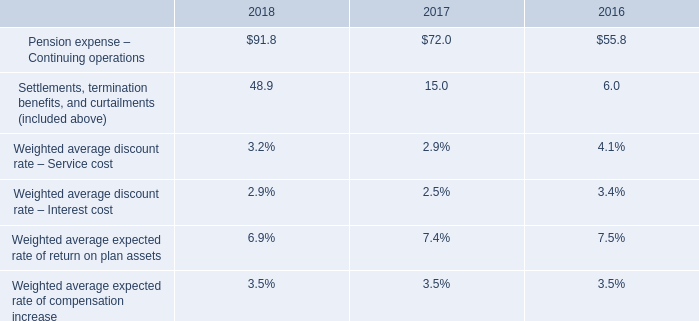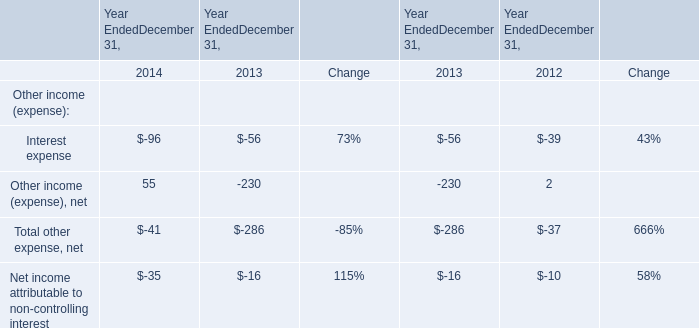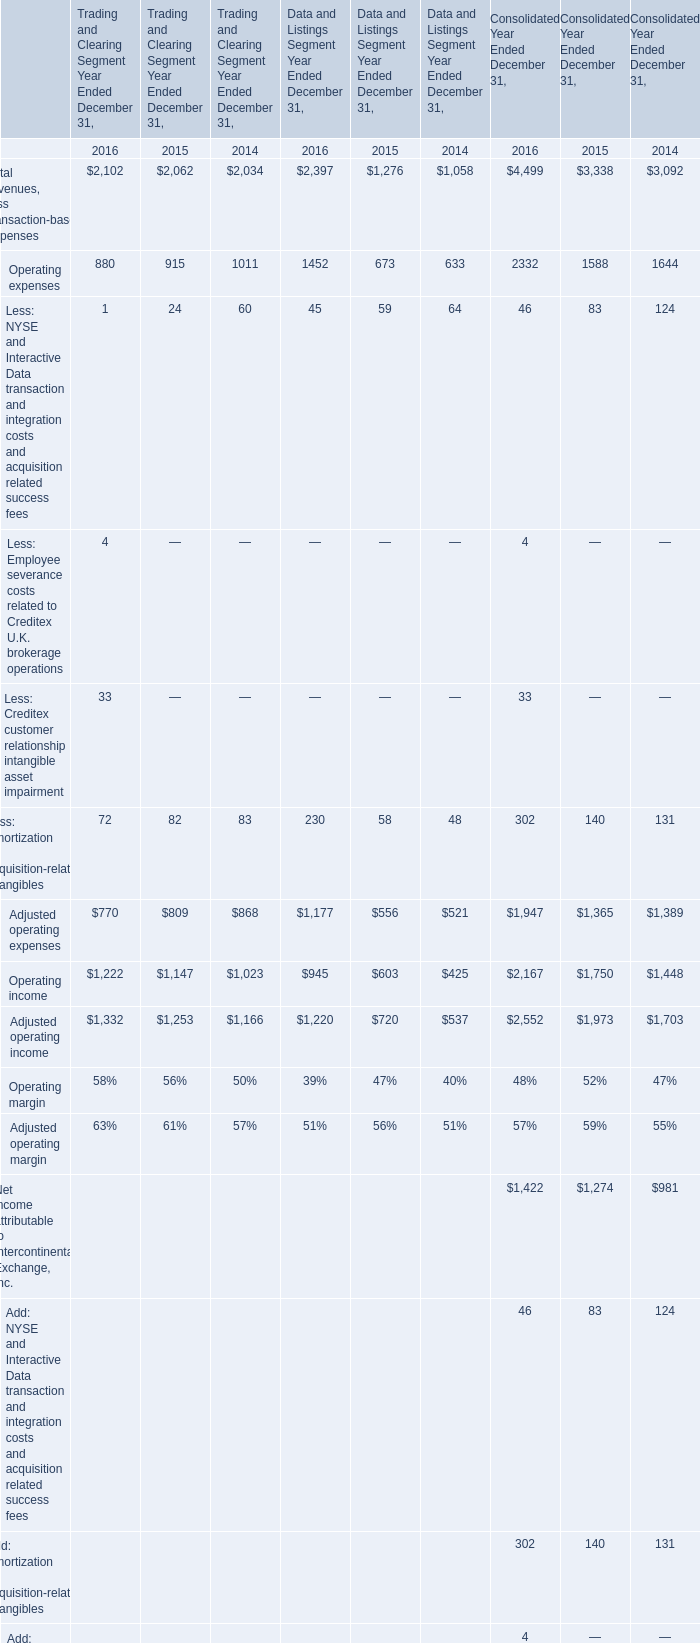What's the total amount of the elements in the years where Operating income for Trading and Clearing Segment Year Ended December 31 is greater than 2100? 
Computations: (((2102 + 880) + 1222) + 1332)
Answer: 5536.0. 